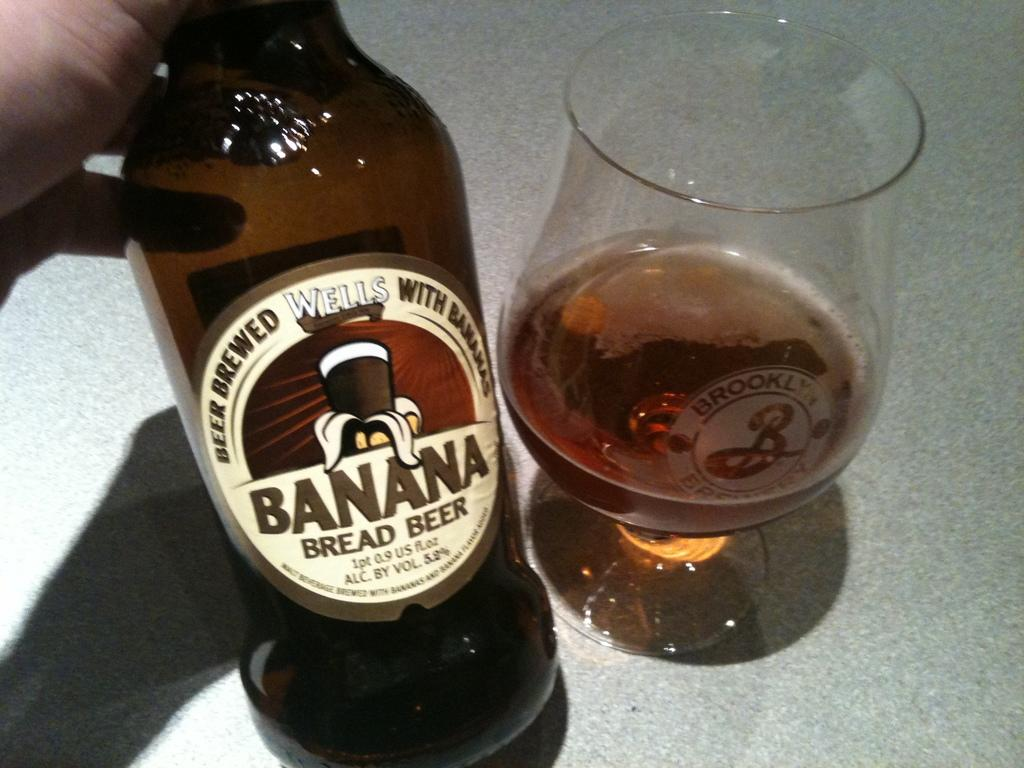<image>
Create a compact narrative representing the image presented. Person holding a Banana Bread Beer next to an almost empty cup of beer. 